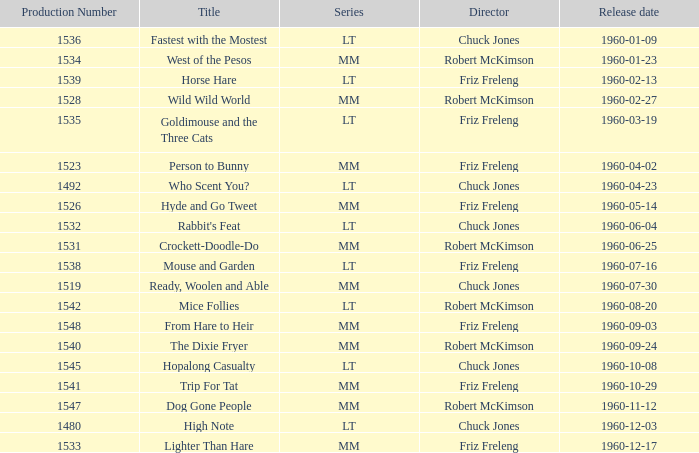Would you mind parsing the complete table? {'header': ['Production Number', 'Title', 'Series', 'Director', 'Release date'], 'rows': [['1536', 'Fastest with the Mostest', 'LT', 'Chuck Jones', '1960-01-09'], ['1534', 'West of the Pesos', 'MM', 'Robert McKimson', '1960-01-23'], ['1539', 'Horse Hare', 'LT', 'Friz Freleng', '1960-02-13'], ['1528', 'Wild Wild World', 'MM', 'Robert McKimson', '1960-02-27'], ['1535', 'Goldimouse and the Three Cats', 'LT', 'Friz Freleng', '1960-03-19'], ['1523', 'Person to Bunny', 'MM', 'Friz Freleng', '1960-04-02'], ['1492', 'Who Scent You?', 'LT', 'Chuck Jones', '1960-04-23'], ['1526', 'Hyde and Go Tweet', 'MM', 'Friz Freleng', '1960-05-14'], ['1532', "Rabbit's Feat", 'LT', 'Chuck Jones', '1960-06-04'], ['1531', 'Crockett-Doodle-Do', 'MM', 'Robert McKimson', '1960-06-25'], ['1538', 'Mouse and Garden', 'LT', 'Friz Freleng', '1960-07-16'], ['1519', 'Ready, Woolen and Able', 'MM', 'Chuck Jones', '1960-07-30'], ['1542', 'Mice Follies', 'LT', 'Robert McKimson', '1960-08-20'], ['1548', 'From Hare to Heir', 'MM', 'Friz Freleng', '1960-09-03'], ['1540', 'The Dixie Fryer', 'MM', 'Robert McKimson', '1960-09-24'], ['1545', 'Hopalong Casualty', 'LT', 'Chuck Jones', '1960-10-08'], ['1541', 'Trip For Tat', 'MM', 'Friz Freleng', '1960-10-29'], ['1547', 'Dog Gone People', 'MM', 'Robert McKimson', '1960-11-12'], ['1480', 'High Note', 'LT', 'Chuck Jones', '1960-12-03'], ['1533', 'Lighter Than Hare', 'MM', 'Friz Freleng', '1960-12-17']]} What is the Series number of the episode with a production number of 1547? MM. 